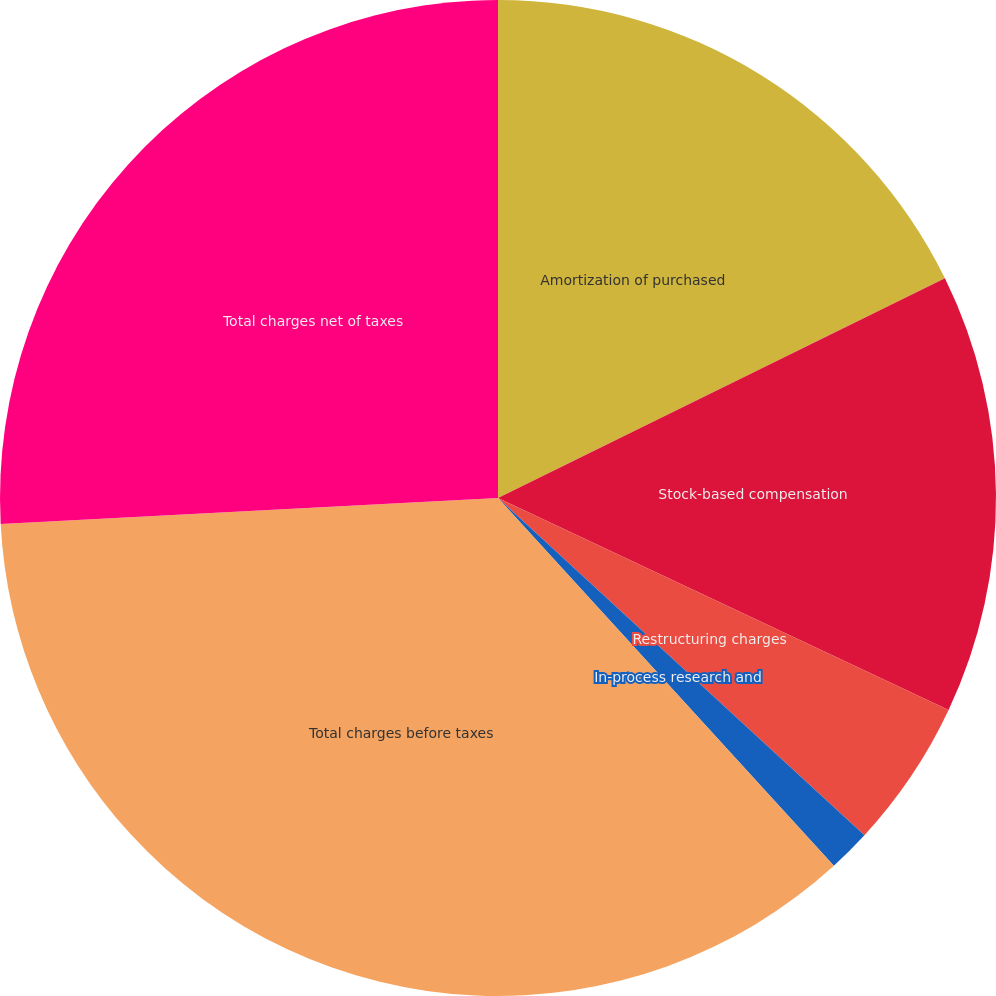Convert chart to OTSL. <chart><loc_0><loc_0><loc_500><loc_500><pie_chart><fcel>Amortization of purchased<fcel>Stock-based compensation<fcel>Restructuring charges<fcel>In-process research and<fcel>Total charges before taxes<fcel>Total charges net of taxes<nl><fcel>17.73%<fcel>14.27%<fcel>4.84%<fcel>1.38%<fcel>35.95%<fcel>25.83%<nl></chart> 